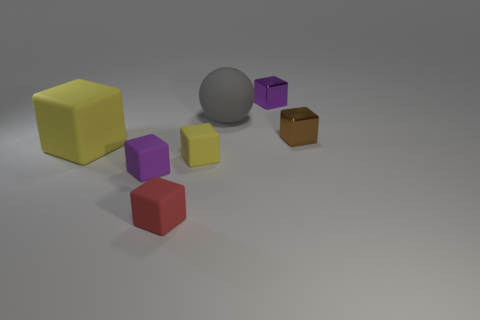What size is the gray matte sphere?
Your answer should be compact. Large. There is a large gray thing; what shape is it?
Offer a very short reply. Sphere. There is a tiny purple matte thing; is it the same shape as the tiny purple object that is behind the matte ball?
Your answer should be very brief. Yes. Does the purple object in front of the large block have the same shape as the large gray matte thing?
Give a very brief answer. No. How many large matte objects are both on the right side of the small purple rubber object and in front of the big gray rubber object?
Ensure brevity in your answer.  0. What number of other things are there of the same size as the brown block?
Ensure brevity in your answer.  4. Are there an equal number of large gray matte spheres that are left of the red block and tiny matte balls?
Your answer should be very brief. Yes. Do the small rubber cube behind the small purple matte thing and the block to the left of the small purple rubber cube have the same color?
Provide a short and direct response. Yes. What is the tiny thing that is in front of the gray object and to the right of the big gray object made of?
Your response must be concise. Metal. The rubber sphere has what color?
Your answer should be very brief. Gray. 